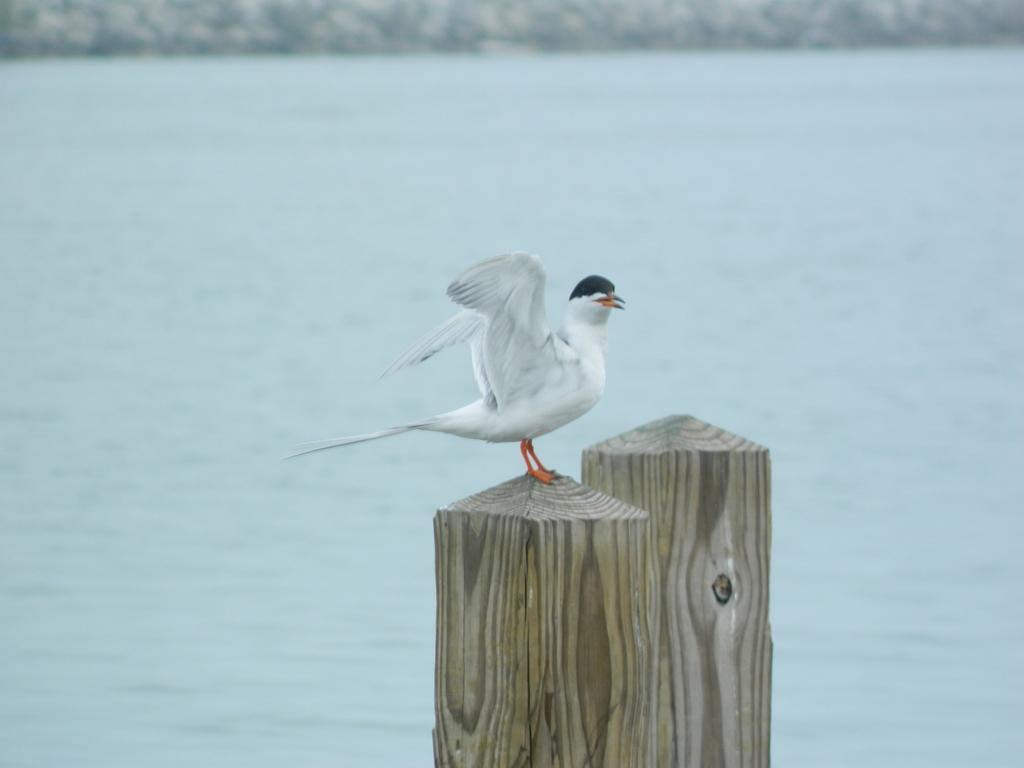Could you give a brief overview of what you see in this image? In the center of the image there is a bird on the wooden pole. In the background of the image there is water. 